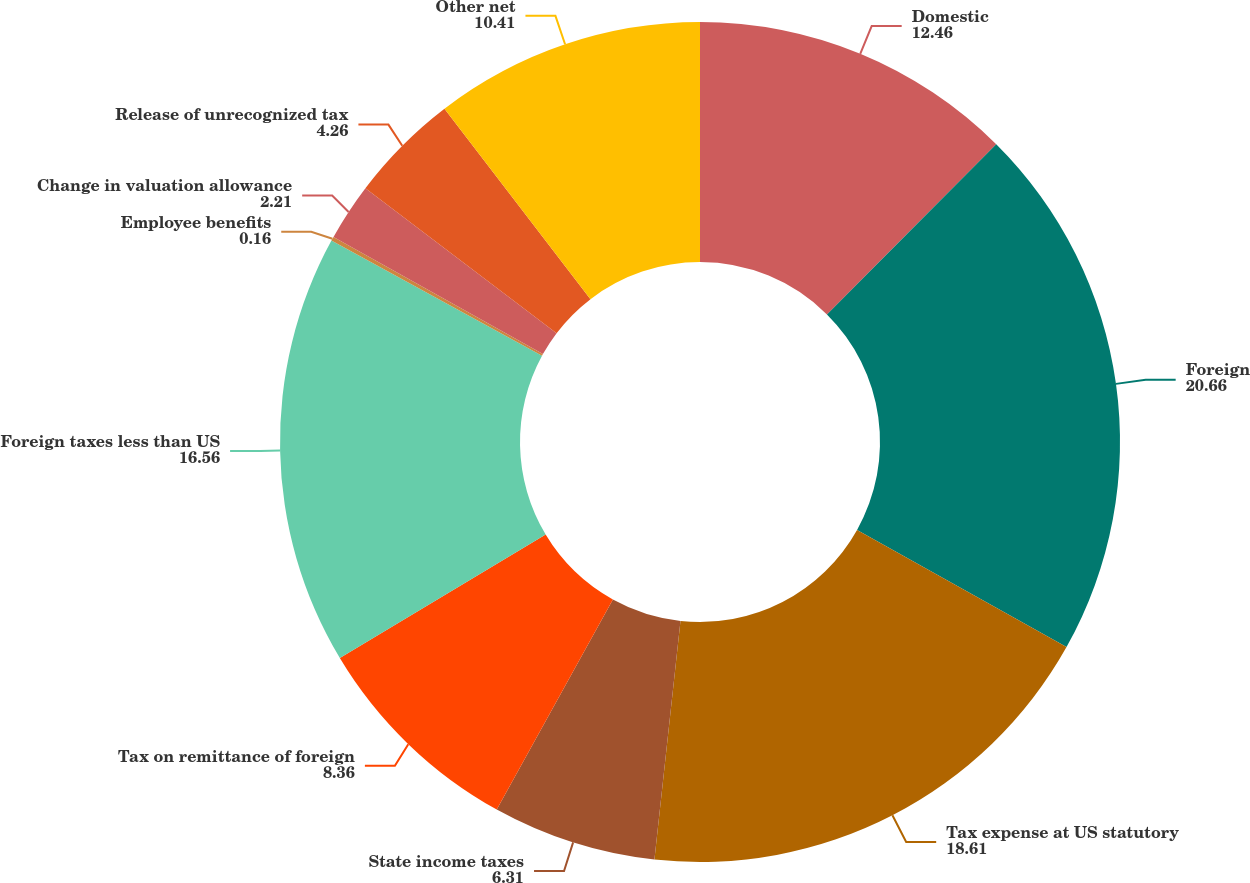<chart> <loc_0><loc_0><loc_500><loc_500><pie_chart><fcel>Domestic<fcel>Foreign<fcel>Tax expense at US statutory<fcel>State income taxes<fcel>Tax on remittance of foreign<fcel>Foreign taxes less than US<fcel>Employee benefits<fcel>Change in valuation allowance<fcel>Release of unrecognized tax<fcel>Other net<nl><fcel>12.46%<fcel>20.66%<fcel>18.61%<fcel>6.31%<fcel>8.36%<fcel>16.56%<fcel>0.16%<fcel>2.21%<fcel>4.26%<fcel>10.41%<nl></chart> 